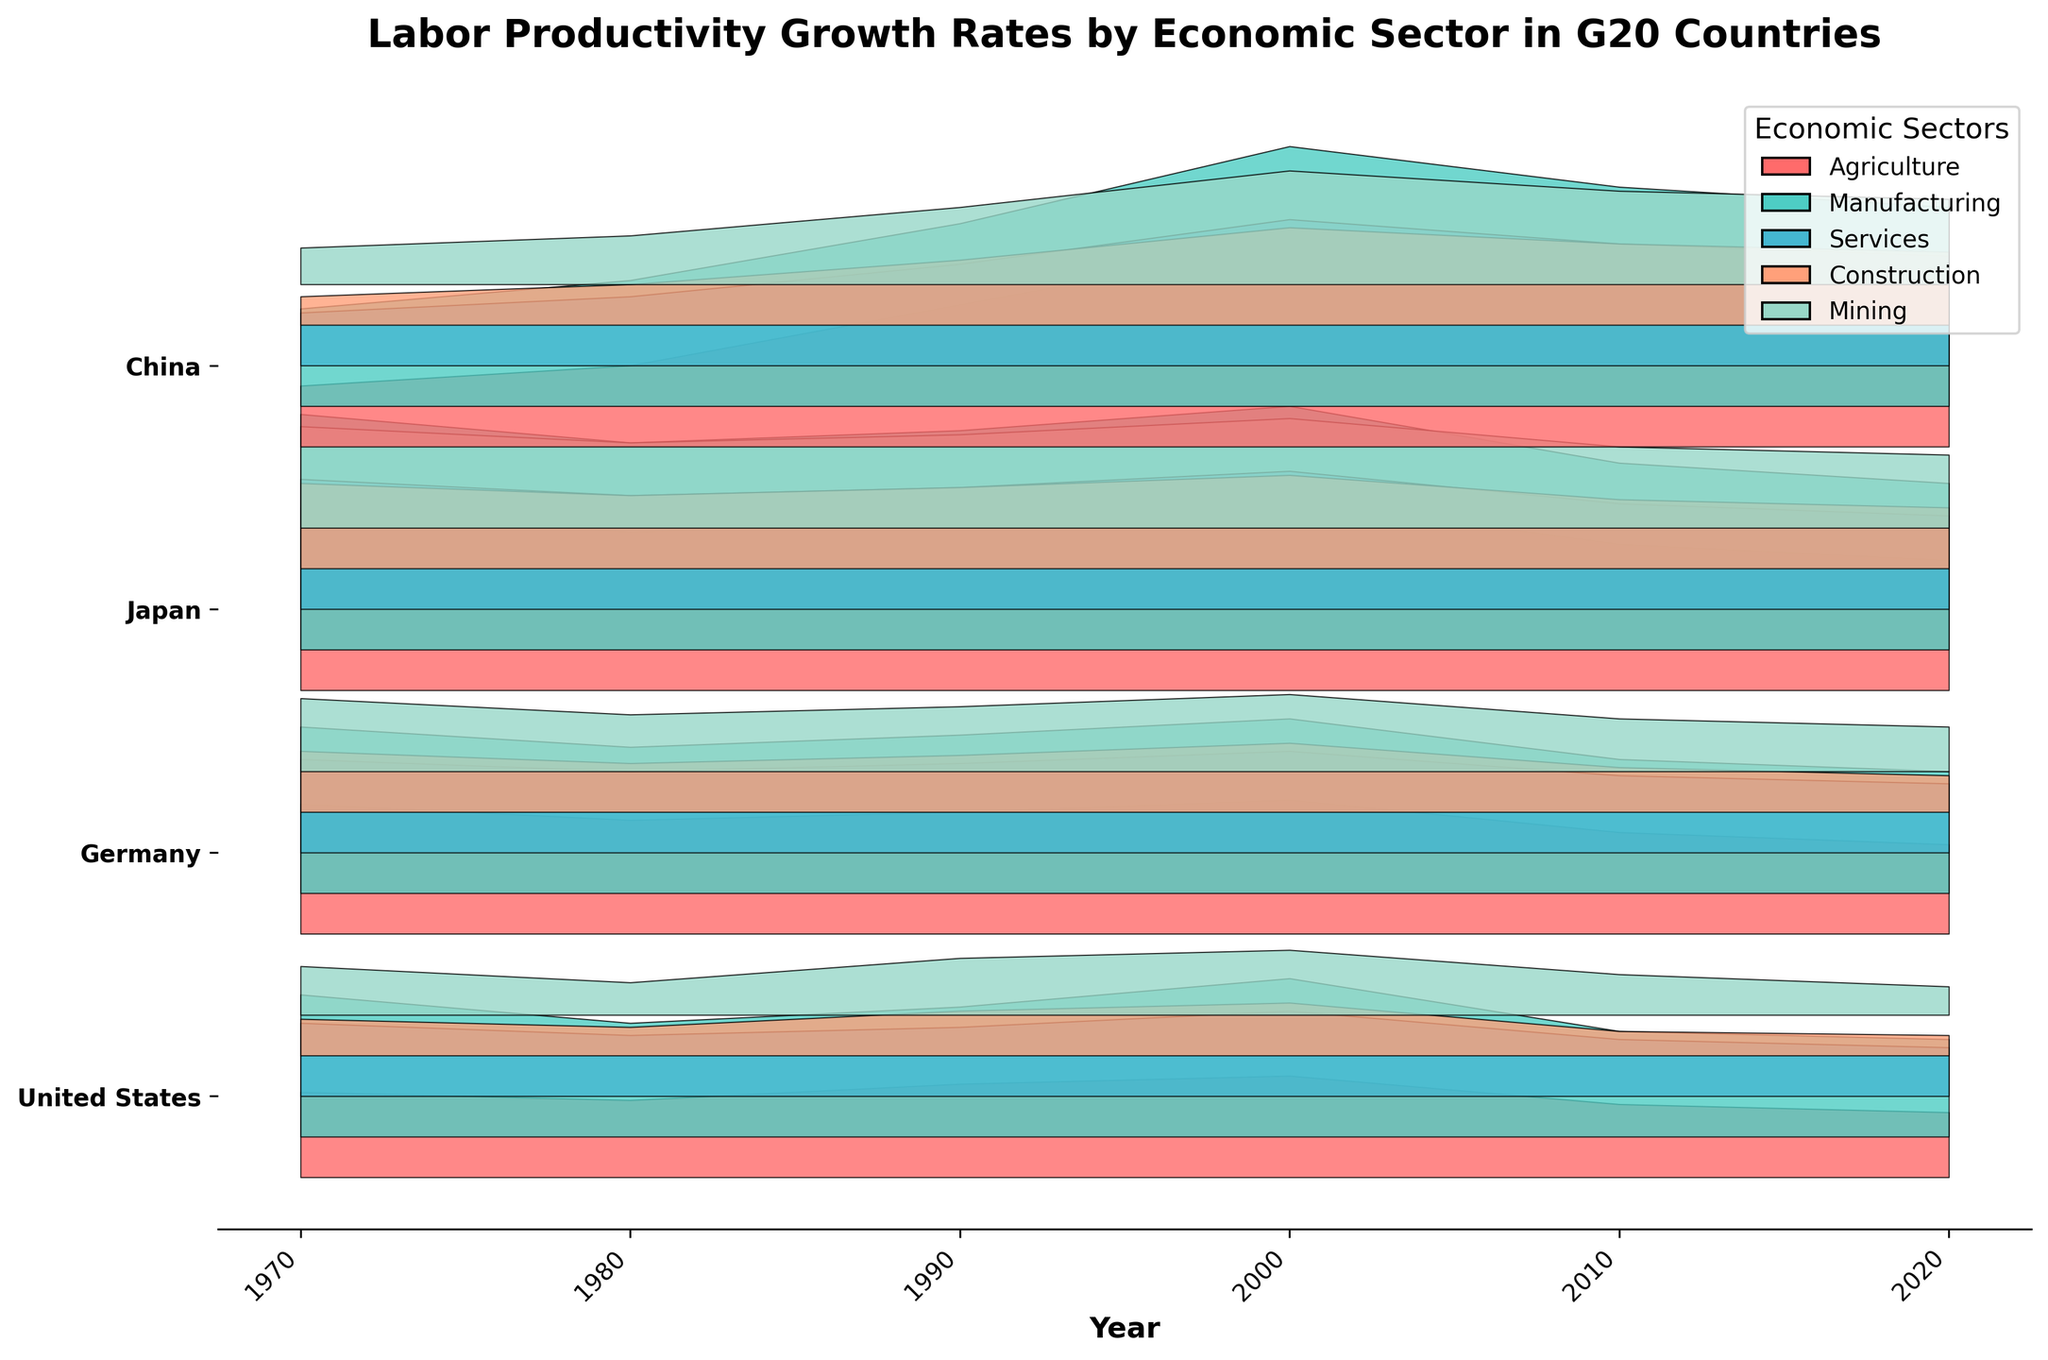What is the title of the plot? The title of the plot is displayed at the top, which summarizes the content of the plot. It reads "Labor Productivity Growth Rates by Economic Sector in G20 Countries".
Answer: Labor Productivity Growth Rates by Economic Sector in G20 Countries What economic sectors are represented in the plot? The legend on the right side of the plot shows the economic sectors represented, which are distinguished by different colors.
Answer: Agriculture, Manufacturing, Services, Construction, Mining Which country shows the highest labor productivity growth in Agriculture in 1970? To find this, look for the country with the highest fill area under the Agriculture sector (usually at the bottom of each country's section) in the year 1970. Japan has the highest value in 1970.
Answer: Japan How did labor productivity growth in the Services sector change in the United States between 1970 and 2020? Compare the heights of the filled area in the Services sector for the United States in the years 1970 and 2020. The height decreased from around 1.8 in 1970 to 1.2 in 2020.
Answer: It decreased Which economic sector had the highest average growth in Germany across all years? Average the heights of the filled areas for each sector across all years for Germany. Manufacturing consistently has the highest values.
Answer: Manufacturing In which year did China experience the most significant growth in labor productivity in Manufacturing? Look at the peaks of the filled areas for Manufacturing in China across the years. The highest peak is in 2000.
Answer: 2000 How does the labor productivity growth in Construction compare between Japan and Germany in 2020? Check the filled areas in the Construction sector for both Japan and Germany in 2020. Japan has higher growth compared to Germany.
Answer: Japan is higher What trend can be observed in Mining sector productivity growth in the United States from 1970 to 2020? Observe the changes in the height of the filled area for the Mining sector in the United States over the years. There is a general decreasing trend from 1970 to 2020.
Answer: Decreasing trend Which sector in Japan had the most stable labor productivity growth from 1970 to 2020? Identify the sector with the smallest variation in the height of the filled area in Japan over the years. Services sector shows the most stability.
Answer: Services 